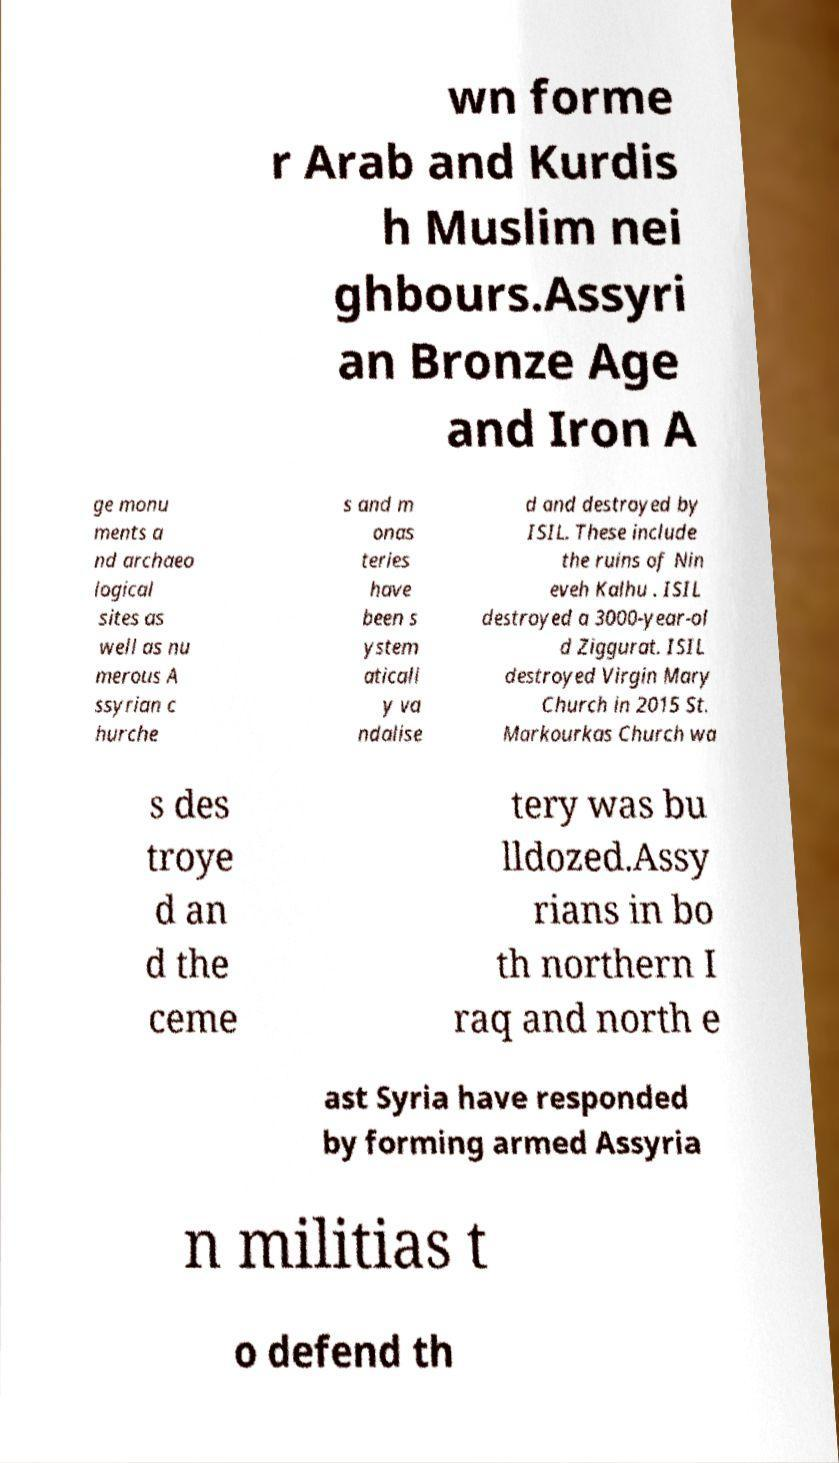Please read and relay the text visible in this image. What does it say? wn forme r Arab and Kurdis h Muslim nei ghbours.Assyri an Bronze Age and Iron A ge monu ments a nd archaeo logical sites as well as nu merous A ssyrian c hurche s and m onas teries have been s ystem aticall y va ndalise d and destroyed by ISIL. These include the ruins of Nin eveh Kalhu . ISIL destroyed a 3000-year-ol d Ziggurat. ISIL destroyed Virgin Mary Church in 2015 St. Markourkas Church wa s des troye d an d the ceme tery was bu lldozed.Assy rians in bo th northern I raq and north e ast Syria have responded by forming armed Assyria n militias t o defend th 